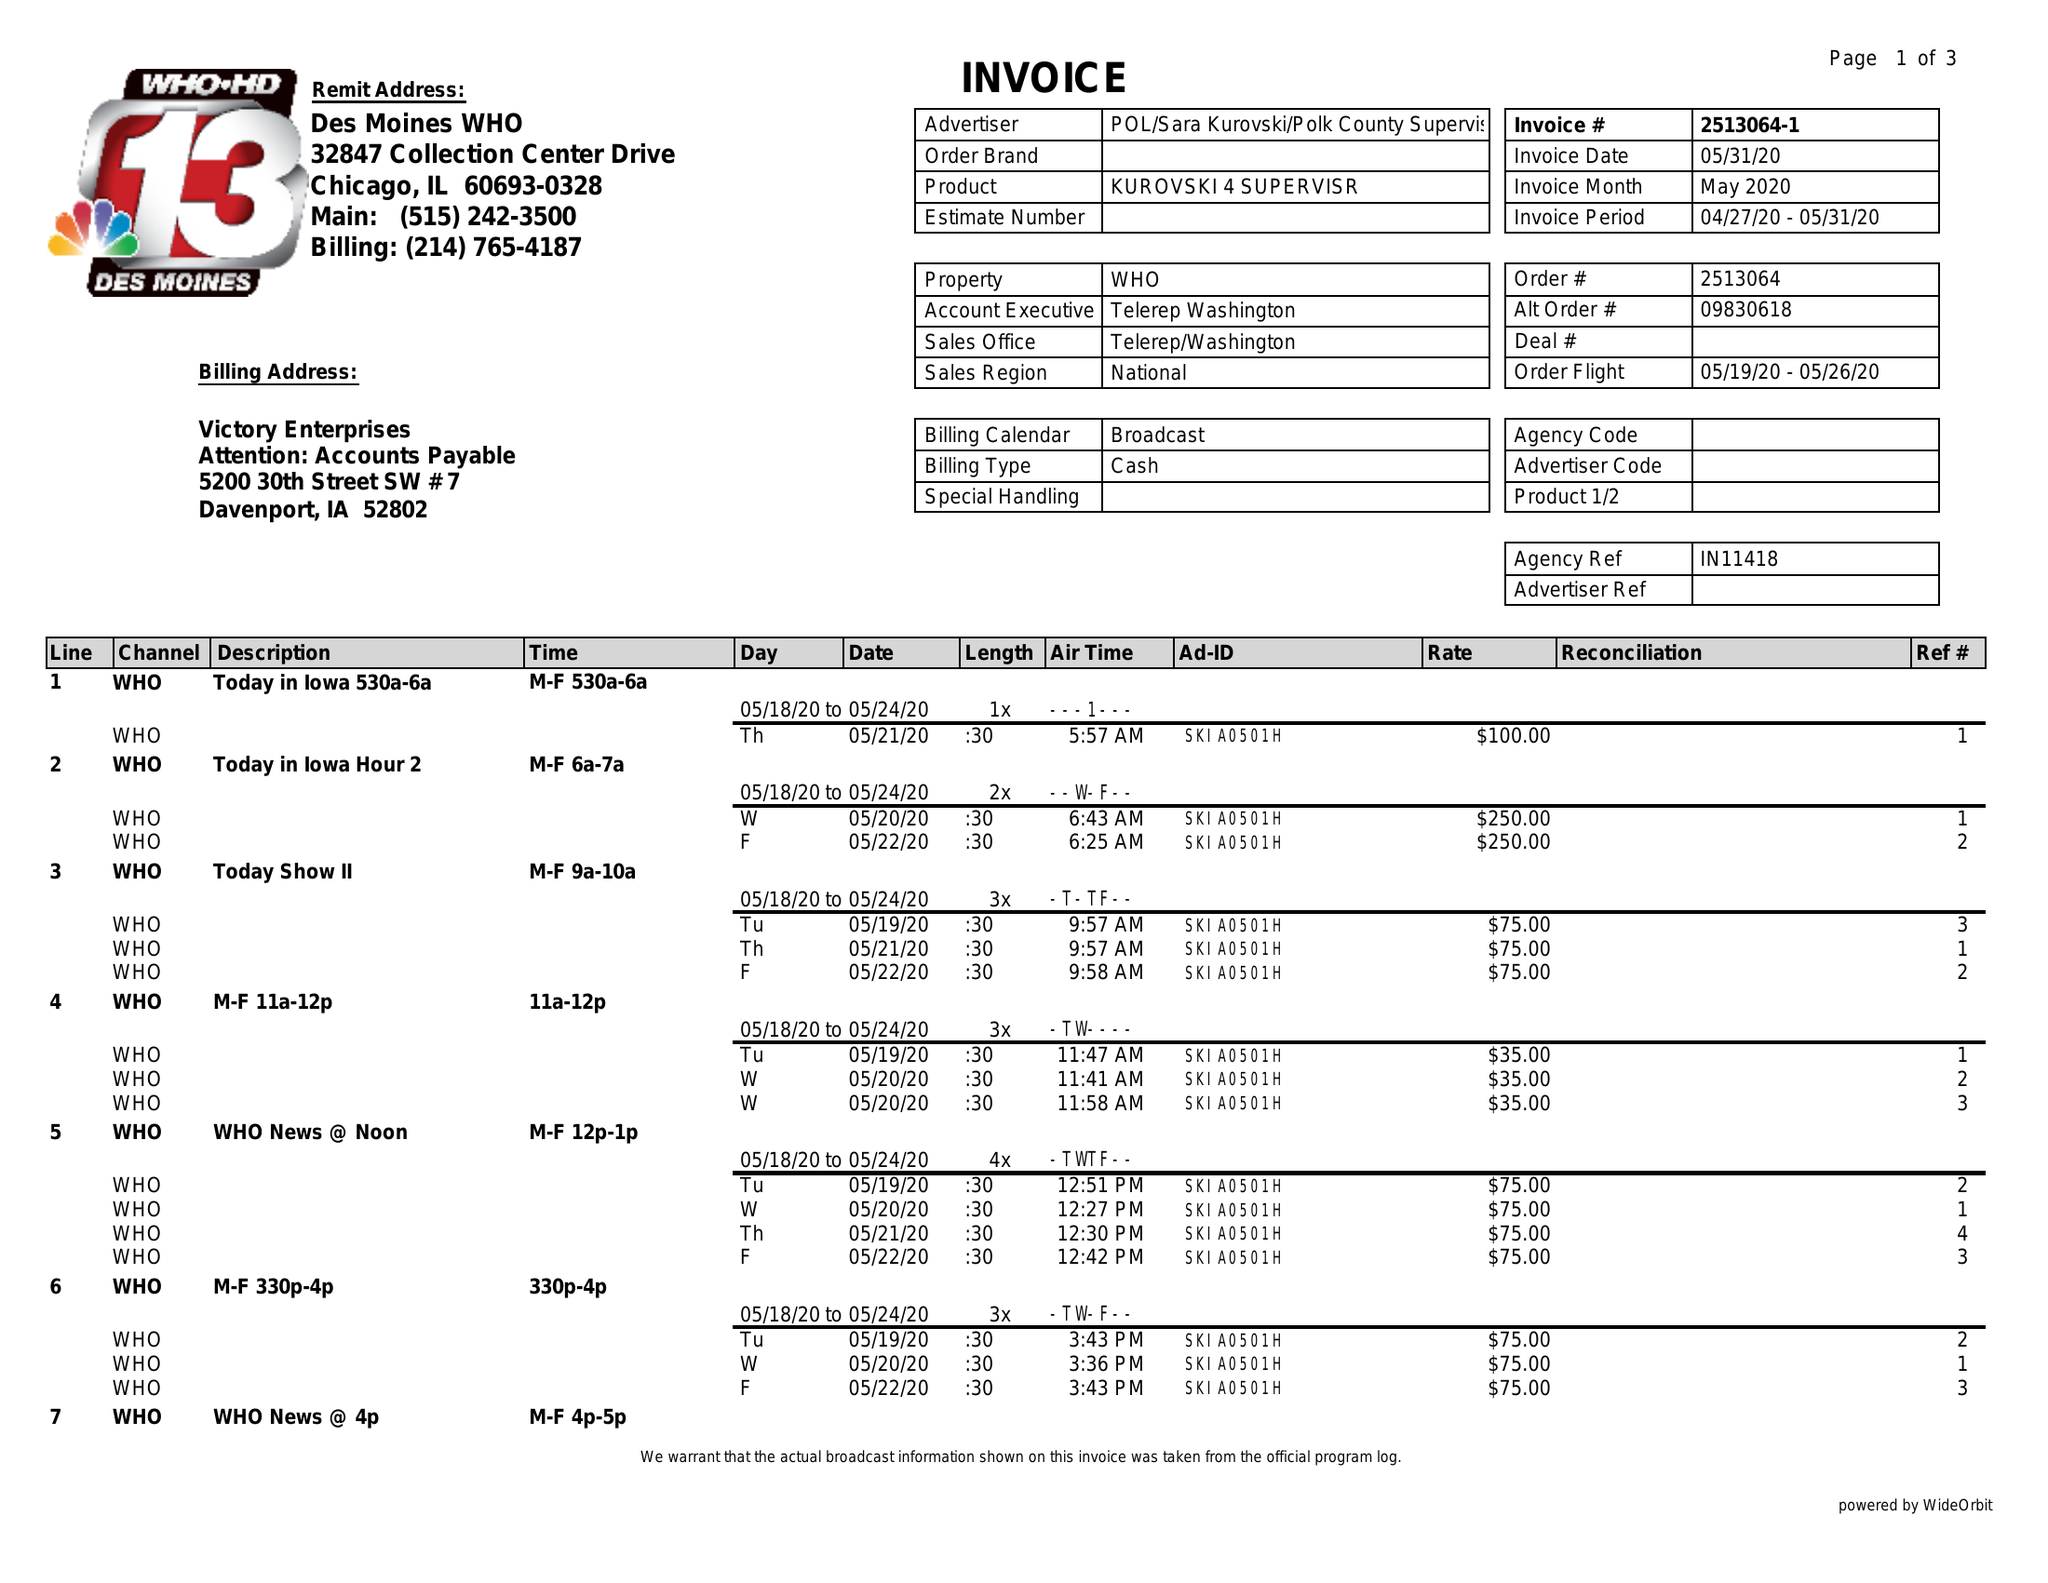What is the value for the flight_to?
Answer the question using a single word or phrase. 05/26/20 